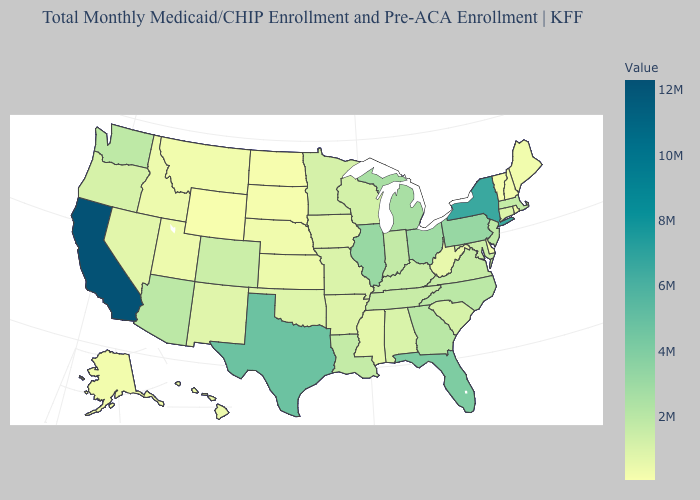Does the map have missing data?
Be succinct. No. Does Mississippi have the lowest value in the South?
Quick response, please. No. 